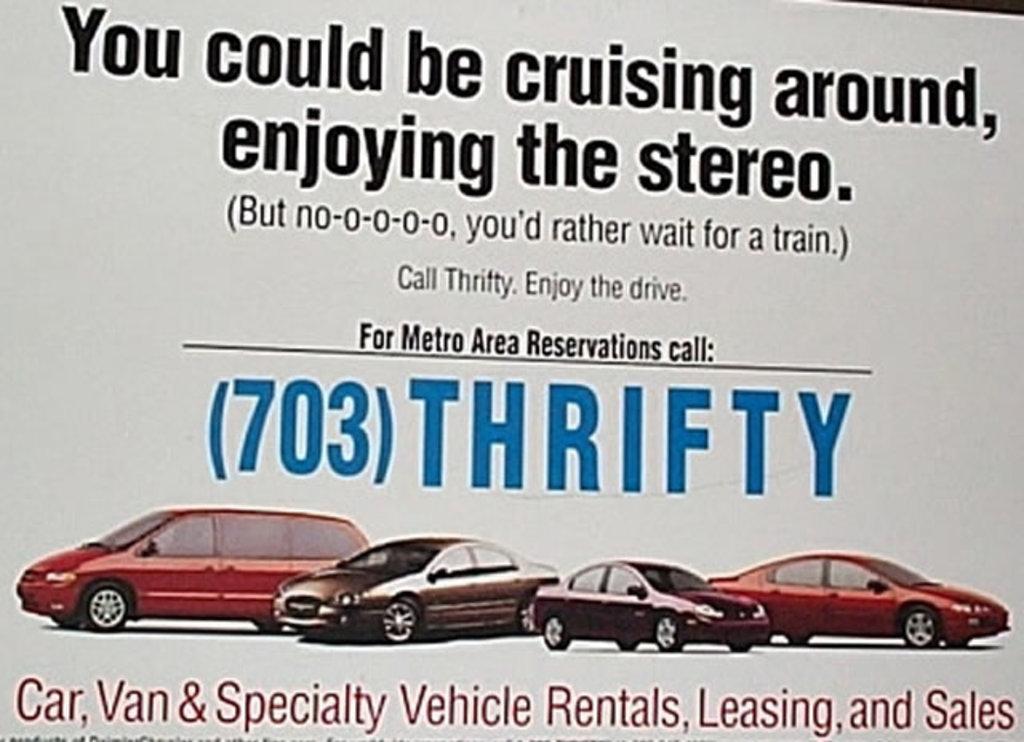Please provide a concise description of this image. In this image, we can see a poster with some images and text. 